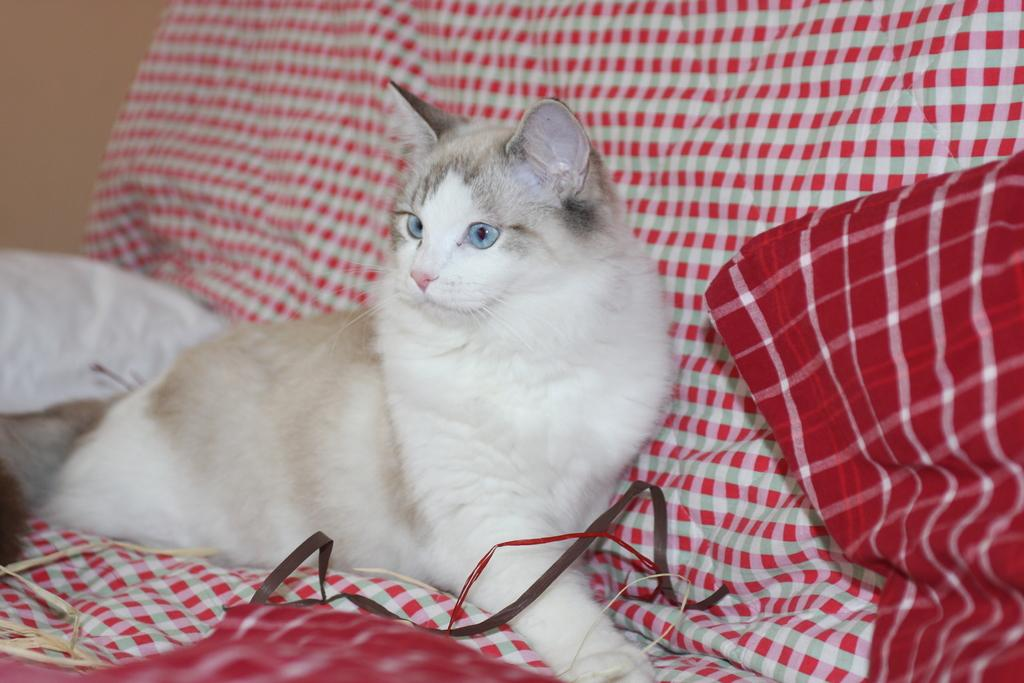What animal is present in the image? There is a cat in the image. Where is the cat located? The cat is sitting on a sofa. What can be observed about the sofa in the image? The sofa has cushions. What type of school can be seen in the image? There is no school present in the image; it features a cat sitting on a sofa. What kind of competition is taking place in the image? There is no competition present in the image; it features a cat sitting on a sofa. 